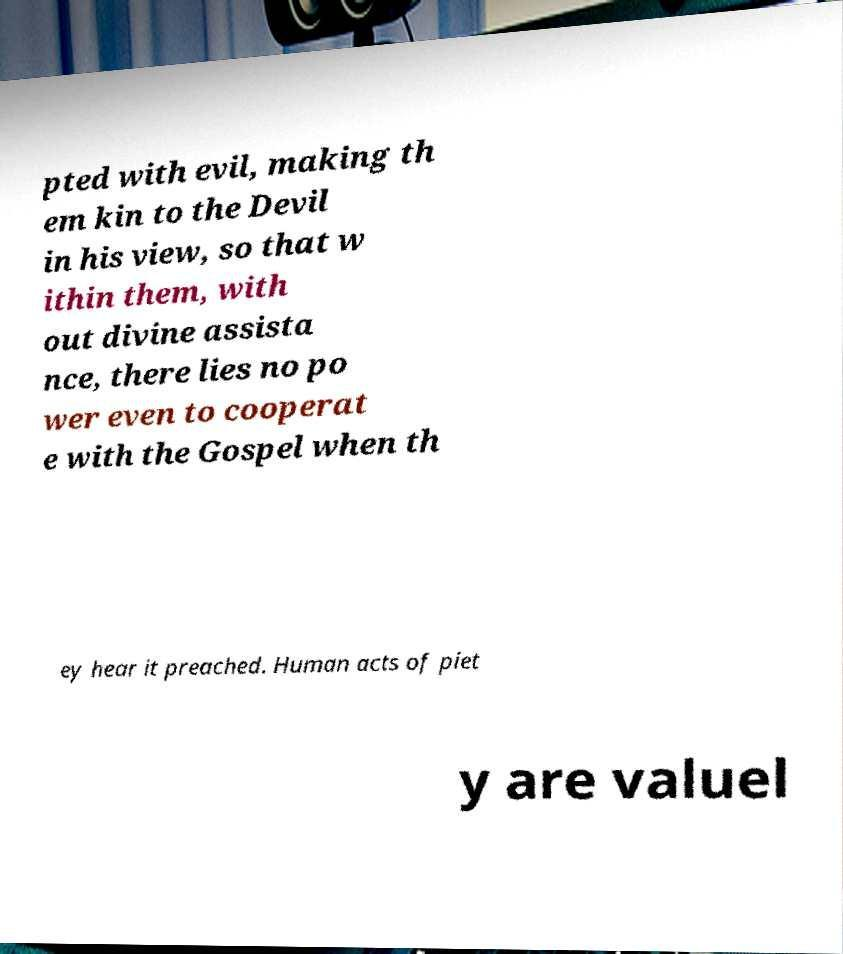For documentation purposes, I need the text within this image transcribed. Could you provide that? pted with evil, making th em kin to the Devil in his view, so that w ithin them, with out divine assista nce, there lies no po wer even to cooperat e with the Gospel when th ey hear it preached. Human acts of piet y are valuel 